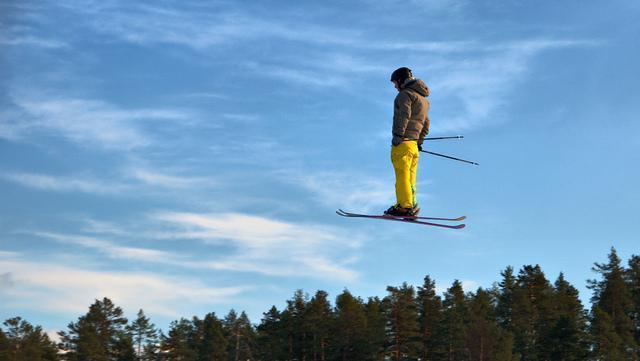How many dog can you see in the image?
Give a very brief answer. 0. 